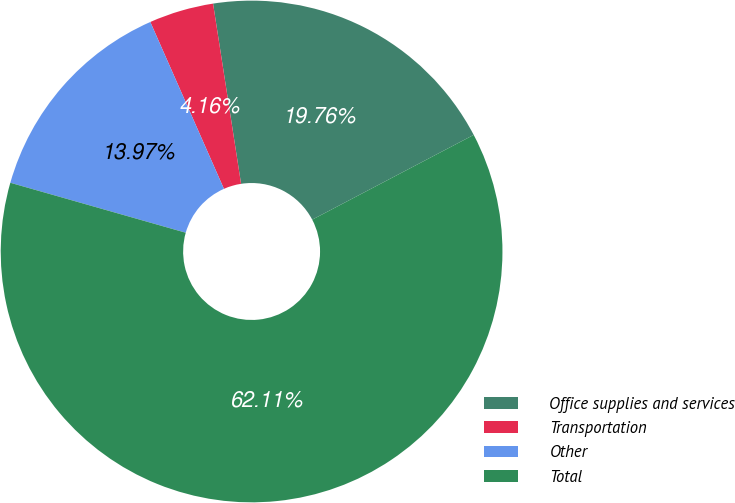Convert chart to OTSL. <chart><loc_0><loc_0><loc_500><loc_500><pie_chart><fcel>Office supplies and services<fcel>Transportation<fcel>Other<fcel>Total<nl><fcel>19.76%<fcel>4.16%<fcel>13.97%<fcel>62.11%<nl></chart> 